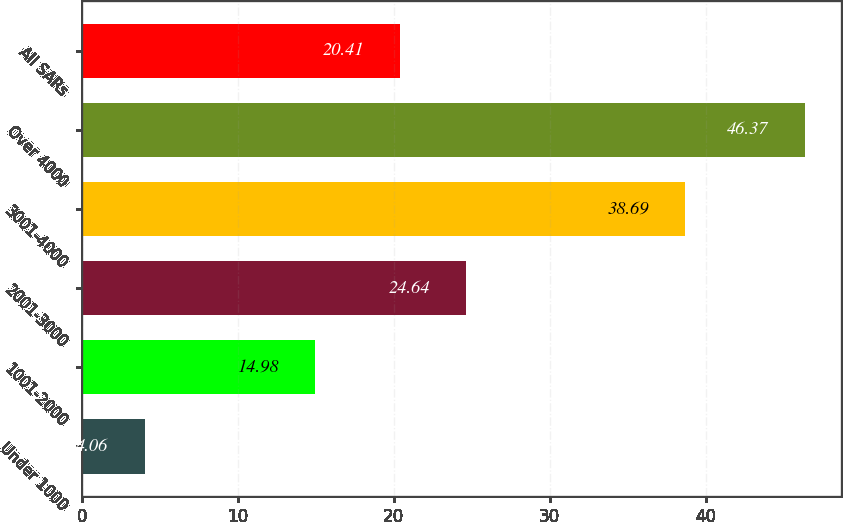Convert chart. <chart><loc_0><loc_0><loc_500><loc_500><bar_chart><fcel>Under 1000<fcel>1001-2000<fcel>2001-3000<fcel>3001-4000<fcel>Over 4000<fcel>All SARs<nl><fcel>4.06<fcel>14.98<fcel>24.64<fcel>38.69<fcel>46.37<fcel>20.41<nl></chart> 